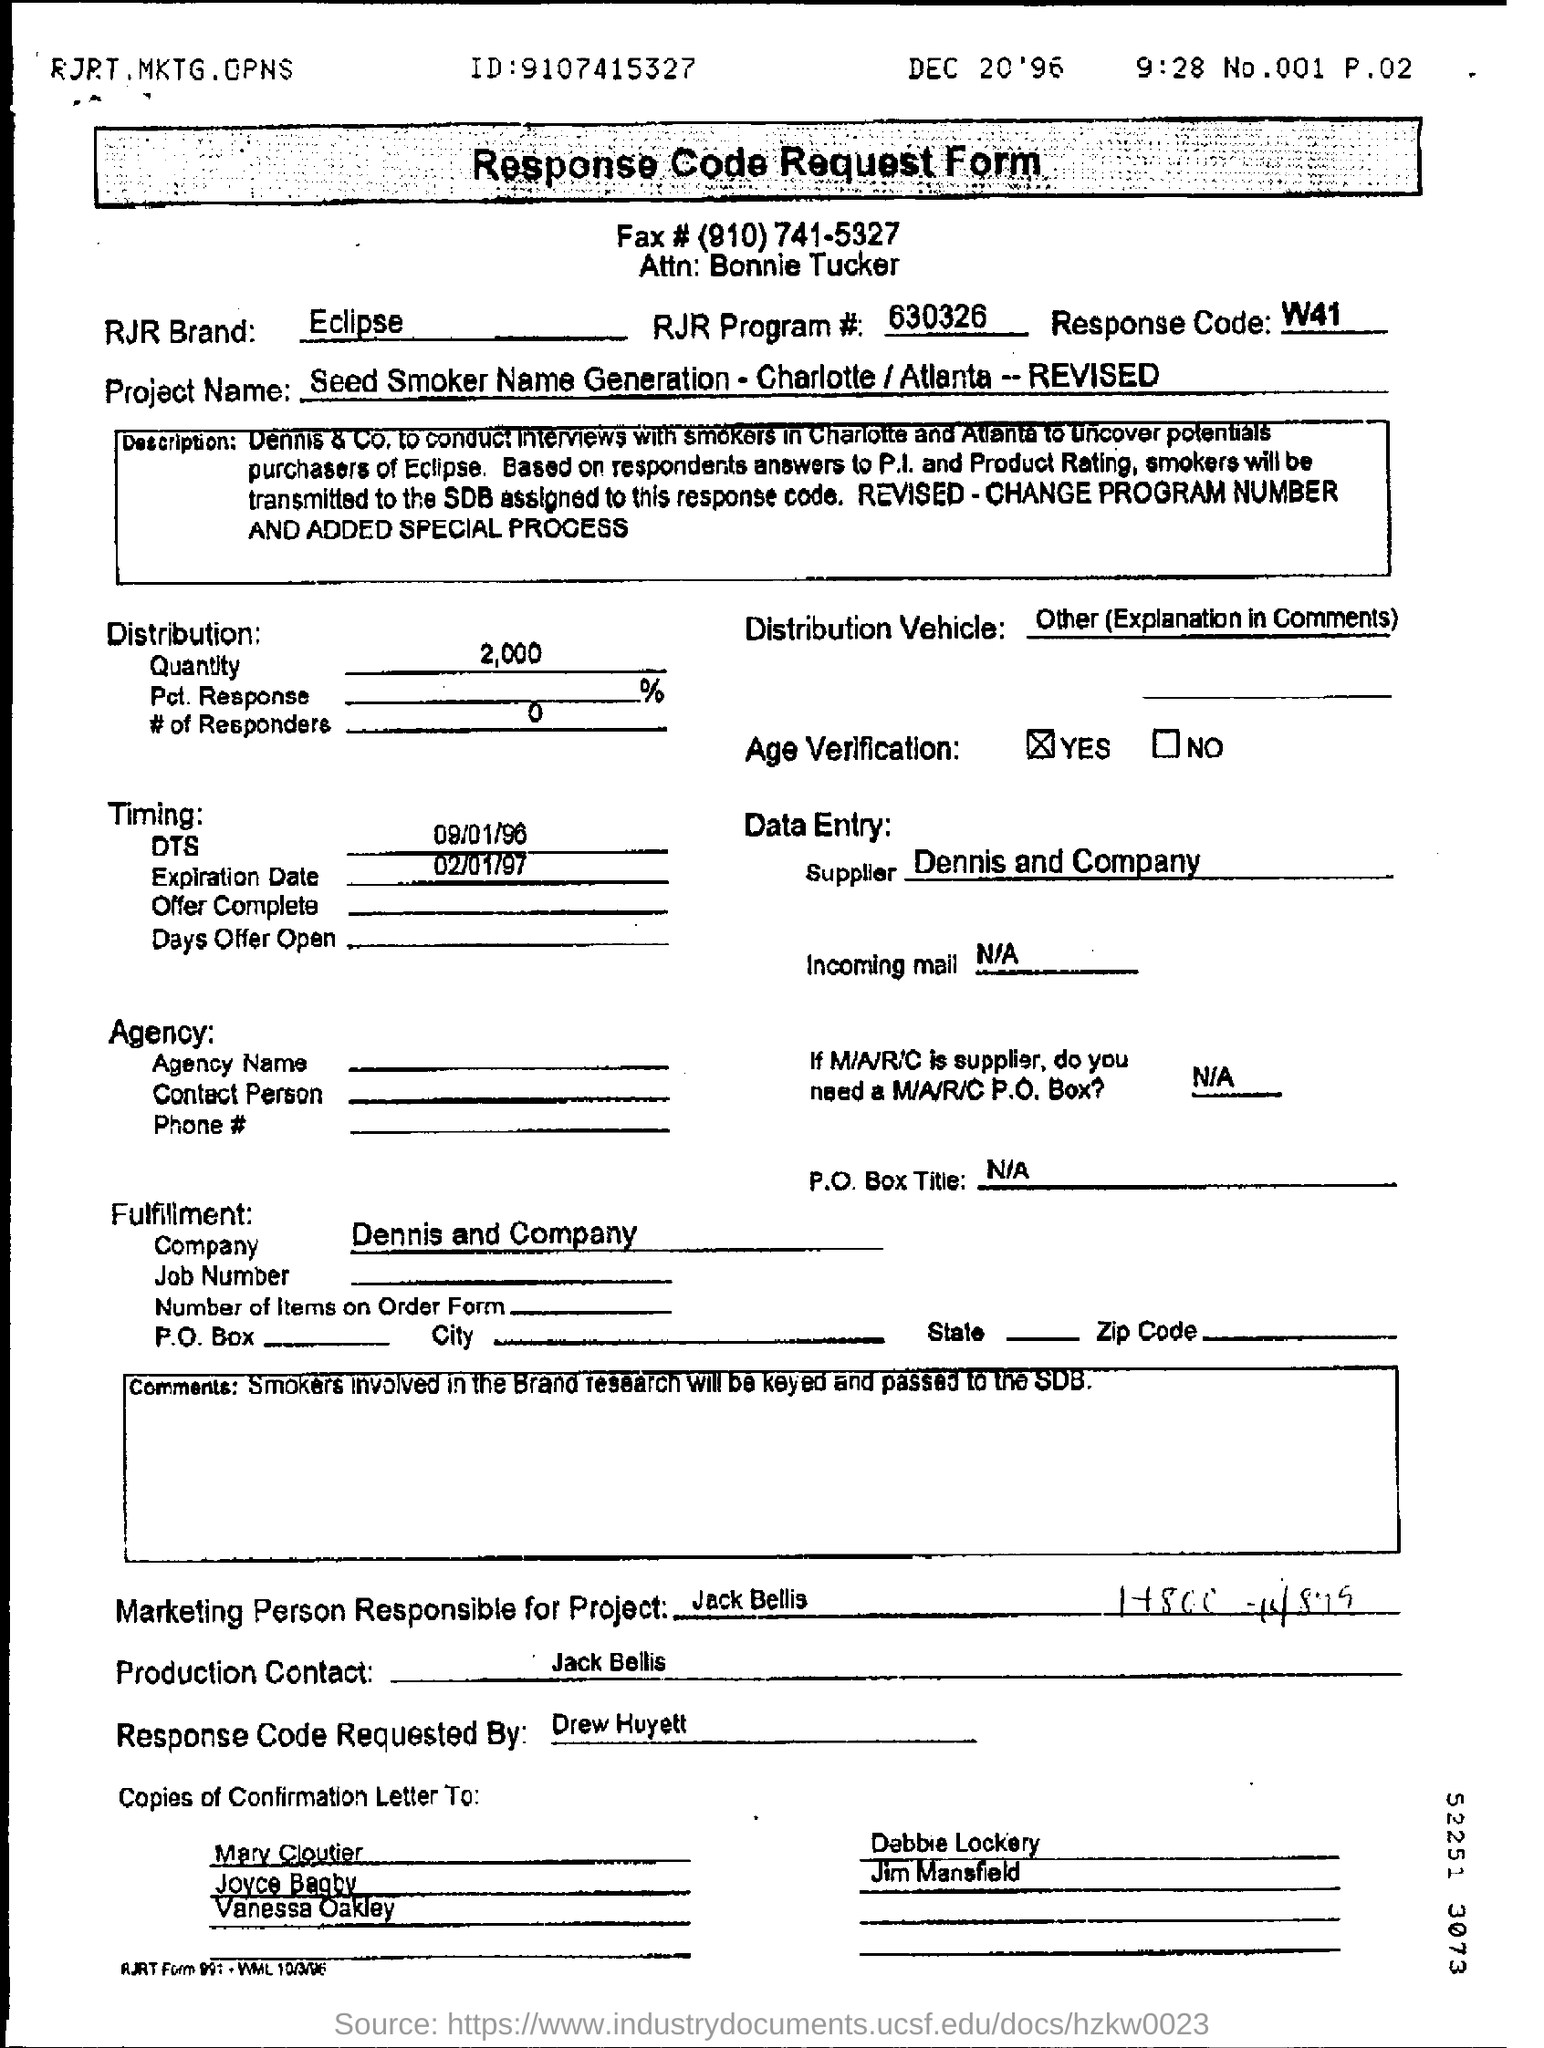Who is the marketing person responsible for the project?
Provide a succinct answer. Jack Bellis. What is the RJR Brand mentioned on the response code request form?
Give a very brief answer. Eclipse. What is the RJR program number mentioned on the response code request form?
Ensure brevity in your answer.  630326. What is the response code mentioned on the form?
Your answer should be very brief. W41. Who is the supplier?
Ensure brevity in your answer.  Dennis and Company. When will the offer expire?
Offer a very short reply. 02/01/97. Who requested the response code request form?
Your response must be concise. Drew Huyett. 